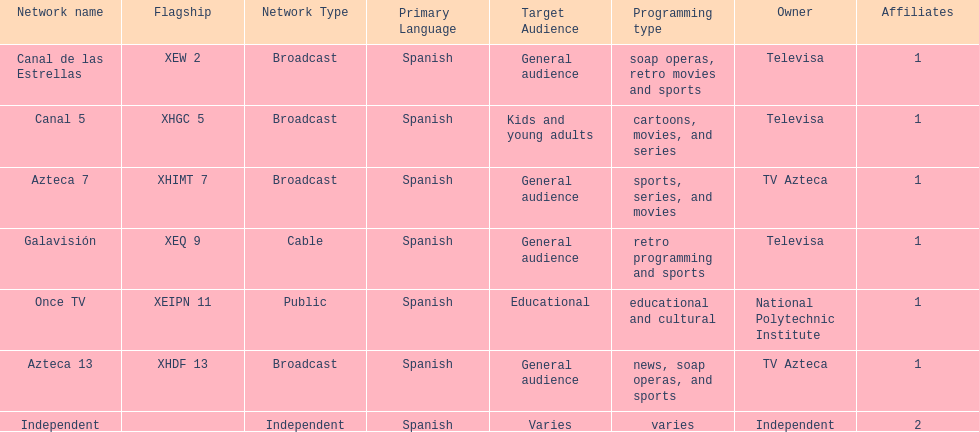Could you parse the entire table as a dict? {'header': ['Network name', 'Flagship', 'Network Type', 'Primary Language', 'Target Audience', 'Programming type', 'Owner', 'Affiliates'], 'rows': [['Canal de las Estrellas', 'XEW 2', 'Broadcast', 'Spanish', 'General audience', 'soap operas, retro movies and sports', 'Televisa', '1'], ['Canal 5', 'XHGC 5', 'Broadcast', 'Spanish', 'Kids and young adults', 'cartoons, movies, and series', 'Televisa', '1'], ['Azteca 7', 'XHIMT 7', 'Broadcast', 'Spanish', 'General audience', 'sports, series, and movies', 'TV Azteca', '1'], ['Galavisión', 'XEQ 9', 'Cable', 'Spanish', 'General audience', 'retro programming and sports', 'Televisa', '1'], ['Once TV', 'XEIPN 11', 'Public', 'Spanish', 'Educational', 'educational and cultural', 'National Polytechnic Institute', '1'], ['Azteca 13', 'XHDF 13', 'Broadcast', 'Spanish', 'General audience', 'news, soap operas, and sports', 'TV Azteca', '1'], ['Independent', '', 'Independent', 'Spanish', 'Varies', 'varies', 'Independent', '2']]} Azteca 7 and azteca 13 are both owned by whom? TV Azteca. 